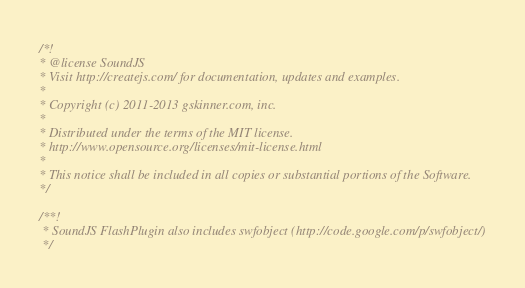<code> <loc_0><loc_0><loc_500><loc_500><_JavaScript_>/*!
* @license SoundJS
* Visit http://createjs.com/ for documentation, updates and examples.
*
* Copyright (c) 2011-2013 gskinner.com, inc.
*
* Distributed under the terms of the MIT license.
* http://www.opensource.org/licenses/mit-license.html
*
* This notice shall be included in all copies or substantial portions of the Software.
*/

/**!
 * SoundJS FlashPlugin also includes swfobject (http://code.google.com/p/swfobject/)
 */
</code> 